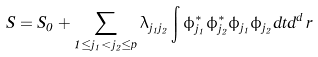Convert formula to latex. <formula><loc_0><loc_0><loc_500><loc_500>S = S _ { 0 } + \sum _ { 1 \leq j _ { 1 } < j _ { 2 } \leq p } \lambda _ { j _ { 1 } j _ { 2 } } \int \phi _ { j _ { 1 } } ^ { * } \phi _ { j _ { 2 } } ^ { * } \phi _ { j _ { 1 } } \phi _ { j _ { 2 } } d t d ^ { d } \, r</formula> 